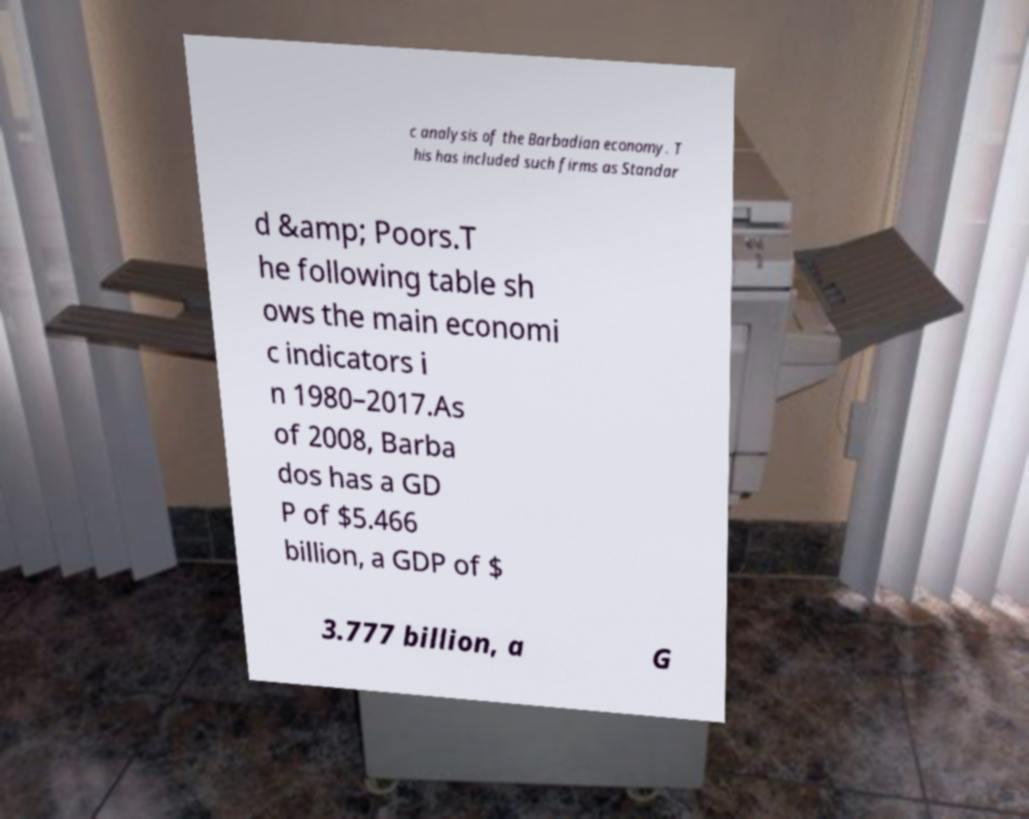There's text embedded in this image that I need extracted. Can you transcribe it verbatim? c analysis of the Barbadian economy. T his has included such firms as Standar d &amp; Poors.T he following table sh ows the main economi c indicators i n 1980–2017.As of 2008, Barba dos has a GD P of $5.466 billion, a GDP of $ 3.777 billion, a G 